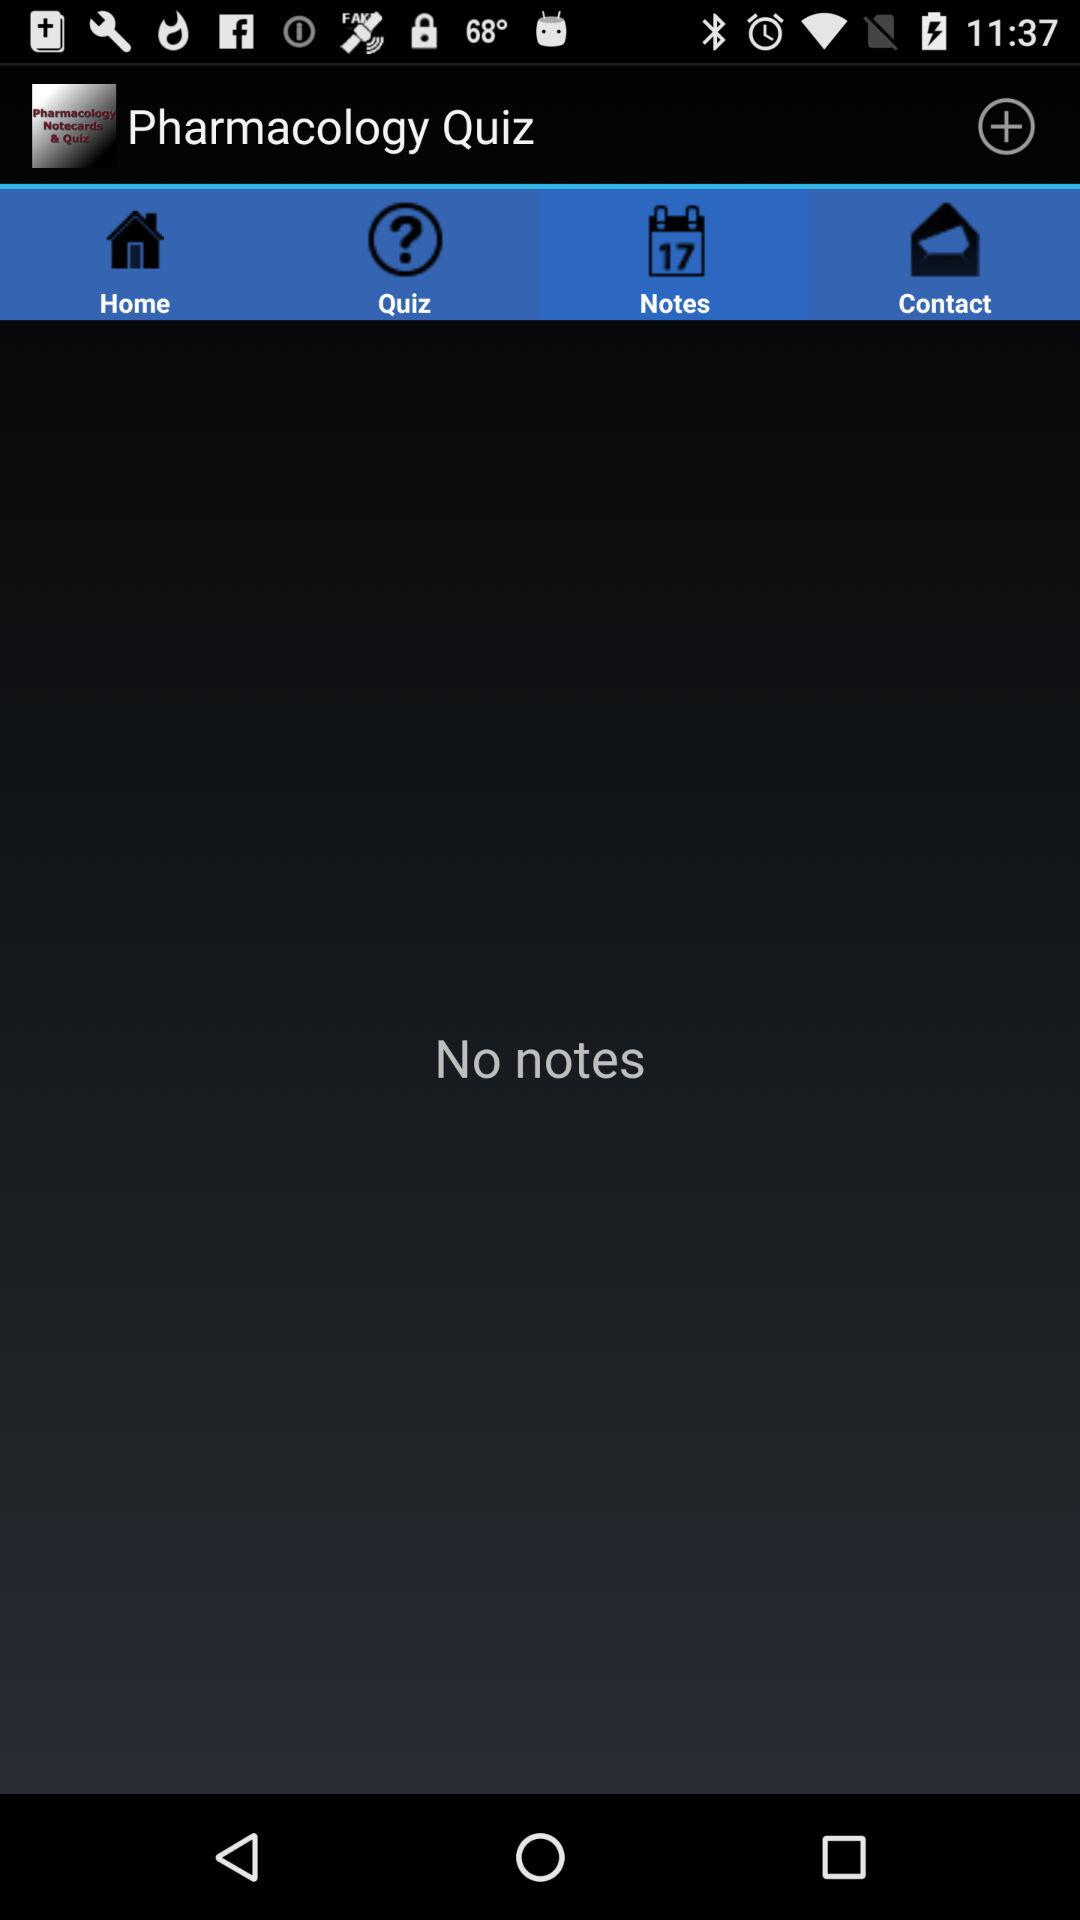Which tab is selected? The selected tab is "Notes". 